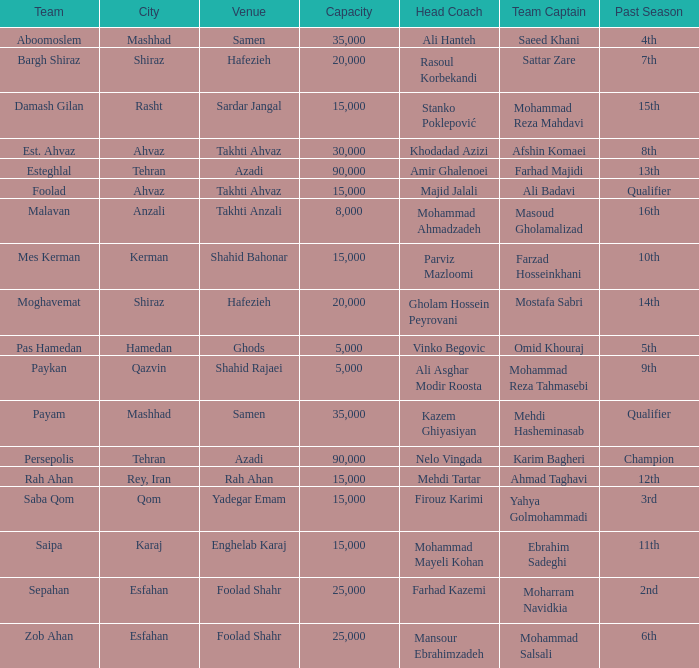Write the full table. {'header': ['Team', 'City', 'Venue', 'Capacity', 'Head Coach', 'Team Captain', 'Past Season'], 'rows': [['Aboomoslem', 'Mashhad', 'Samen', '35,000', 'Ali Hanteh', 'Saeed Khani', '4th'], ['Bargh Shiraz', 'Shiraz', 'Hafezieh', '20,000', 'Rasoul Korbekandi', 'Sattar Zare', '7th'], ['Damash Gilan', 'Rasht', 'Sardar Jangal', '15,000', 'Stanko Poklepović', 'Mohammad Reza Mahdavi', '15th'], ['Est. Ahvaz', 'Ahvaz', 'Takhti Ahvaz', '30,000', 'Khodadad Azizi', 'Afshin Komaei', '8th'], ['Esteghlal', 'Tehran', 'Azadi', '90,000', 'Amir Ghalenoei', 'Farhad Majidi', '13th'], ['Foolad', 'Ahvaz', 'Takhti Ahvaz', '15,000', 'Majid Jalali', 'Ali Badavi', 'Qualifier'], ['Malavan', 'Anzali', 'Takhti Anzali', '8,000', 'Mohammad Ahmadzadeh', 'Masoud Gholamalizad', '16th'], ['Mes Kerman', 'Kerman', 'Shahid Bahonar', '15,000', 'Parviz Mazloomi', 'Farzad Hosseinkhani', '10th'], ['Moghavemat', 'Shiraz', 'Hafezieh', '20,000', 'Gholam Hossein Peyrovani', 'Mostafa Sabri', '14th'], ['Pas Hamedan', 'Hamedan', 'Ghods', '5,000', 'Vinko Begovic', 'Omid Khouraj', '5th'], ['Paykan', 'Qazvin', 'Shahid Rajaei', '5,000', 'Ali Asghar Modir Roosta', 'Mohammad Reza Tahmasebi', '9th'], ['Payam', 'Mashhad', 'Samen', '35,000', 'Kazem Ghiyasiyan', 'Mehdi Hasheminasab', 'Qualifier'], ['Persepolis', 'Tehran', 'Azadi', '90,000', 'Nelo Vingada', 'Karim Bagheri', 'Champion'], ['Rah Ahan', 'Rey, Iran', 'Rah Ahan', '15,000', 'Mehdi Tartar', 'Ahmad Taghavi', '12th'], ['Saba Qom', 'Qom', 'Yadegar Emam', '15,000', 'Firouz Karimi', 'Yahya Golmohammadi', '3rd'], ['Saipa', 'Karaj', 'Enghelab Karaj', '15,000', 'Mohammad Mayeli Kohan', 'Ebrahim Sadeghi', '11th'], ['Sepahan', 'Esfahan', 'Foolad Shahr', '25,000', 'Farhad Kazemi', 'Moharram Navidkia', '2nd'], ['Zob Ahan', 'Esfahan', 'Foolad Shahr', '25,000', 'Mansour Ebrahimzadeh', 'Mohammad Salsali', '6th']]} At which location was there a past season with a 2nd place finish? Foolad Shahr. 